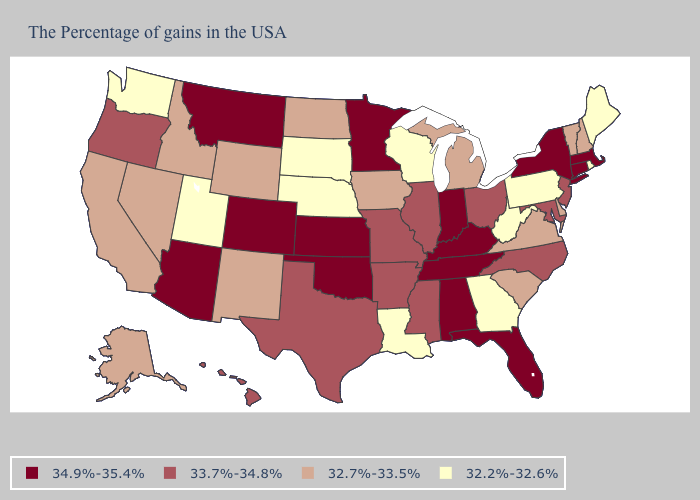Among the states that border Nevada , does Oregon have the lowest value?
Quick response, please. No. Among the states that border Delaware , which have the lowest value?
Quick response, please. Pennsylvania. Which states have the lowest value in the USA?
Quick response, please. Maine, Rhode Island, Pennsylvania, West Virginia, Georgia, Wisconsin, Louisiana, Nebraska, South Dakota, Utah, Washington. Does New Jersey have the same value as Illinois?
Short answer required. Yes. Among the states that border Iowa , which have the highest value?
Answer briefly. Minnesota. Does the first symbol in the legend represent the smallest category?
Quick response, please. No. Does Missouri have the highest value in the MidWest?
Concise answer only. No. What is the value of Michigan?
Answer briefly. 32.7%-33.5%. What is the lowest value in the MidWest?
Keep it brief. 32.2%-32.6%. What is the value of Tennessee?
Keep it brief. 34.9%-35.4%. Does the first symbol in the legend represent the smallest category?
Answer briefly. No. How many symbols are there in the legend?
Quick response, please. 4. Which states have the lowest value in the South?
Be succinct. West Virginia, Georgia, Louisiana. What is the highest value in states that border Oklahoma?
Be succinct. 34.9%-35.4%. Does Maine have the lowest value in the USA?
Concise answer only. Yes. 